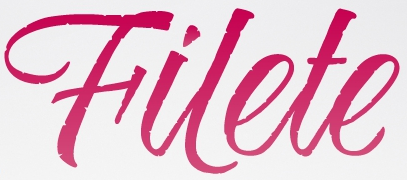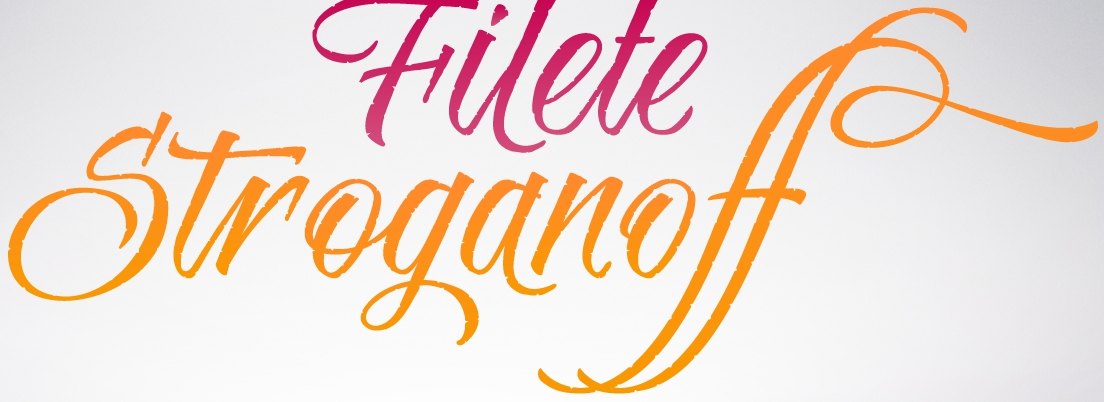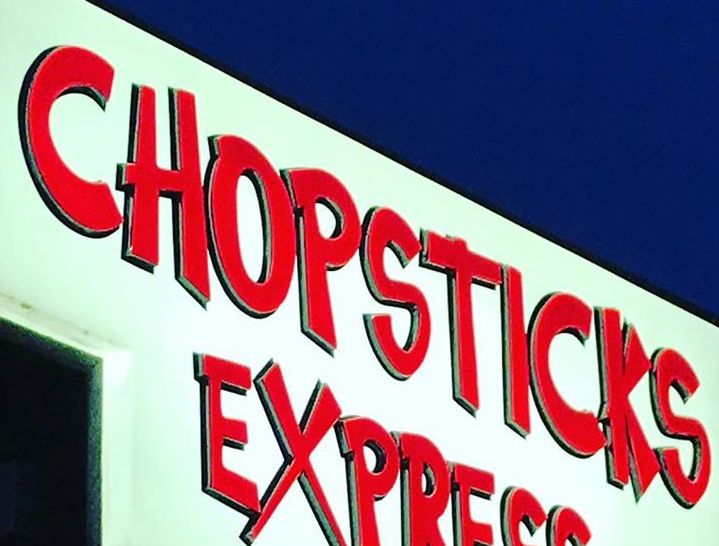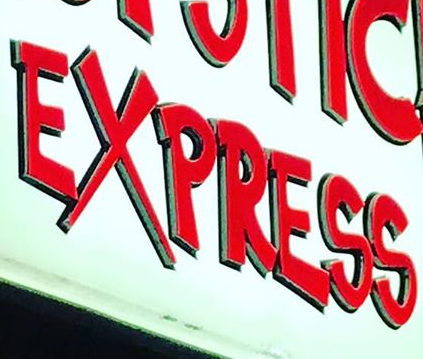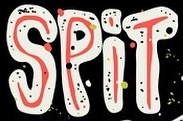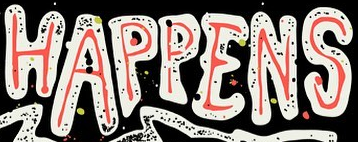Transcribe the words shown in these images in order, separated by a semicolon. Hilete; Stroganoff; CHOPSTICKS; EXPRESS; SPiT; HAPPENS 